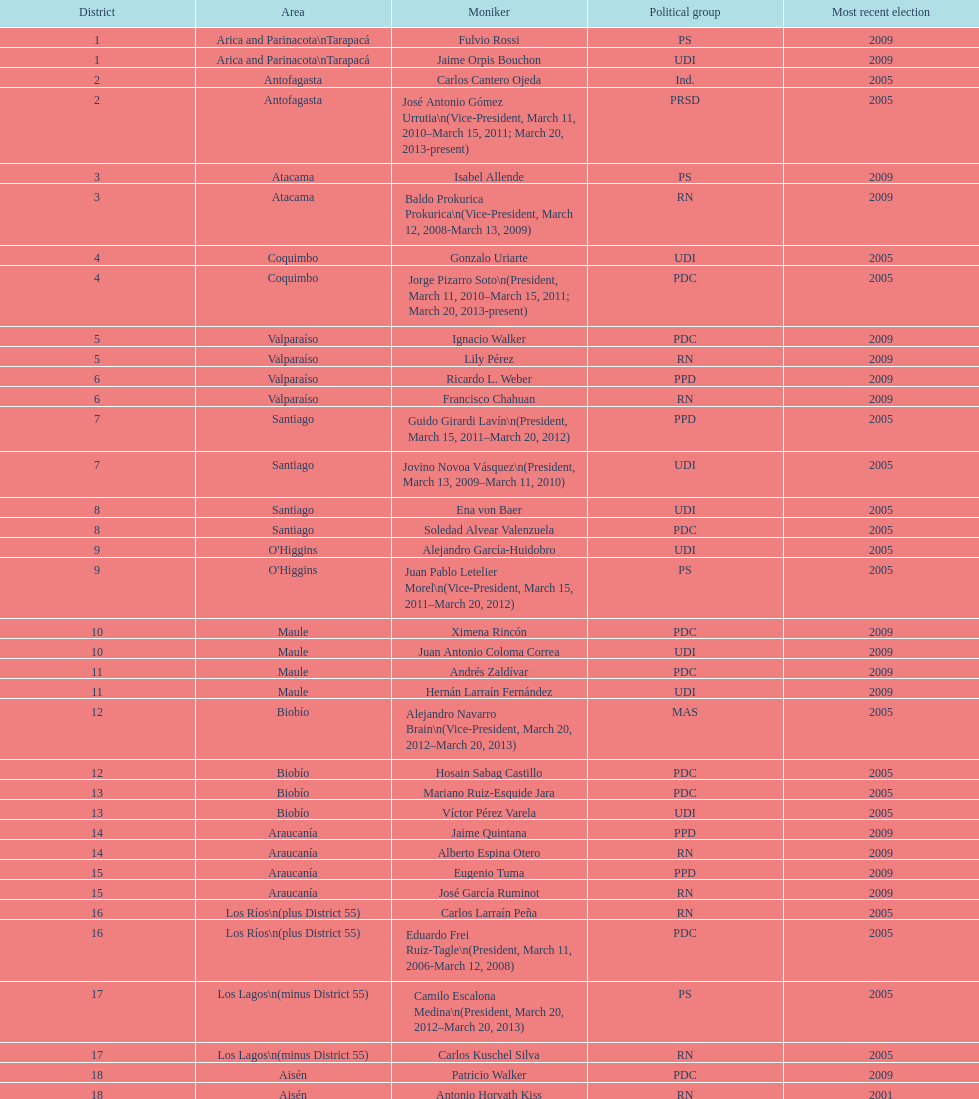What is the difference in years between constiuency 1 and 2? 4 years. 